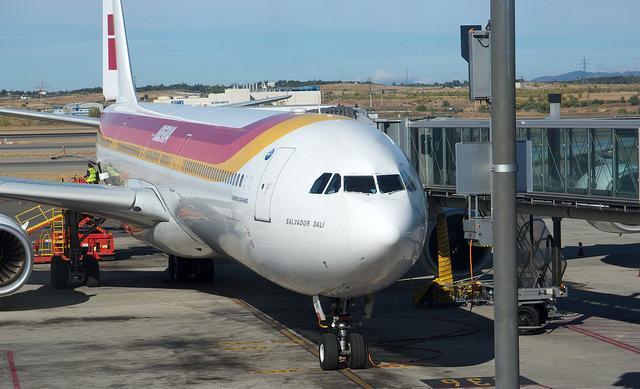How many airplanes are there?
Give a very brief answer. 1. 